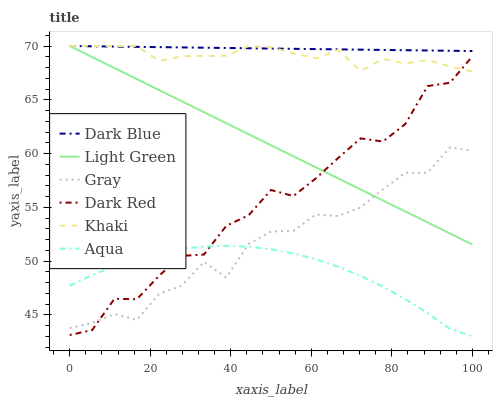Does Khaki have the minimum area under the curve?
Answer yes or no. No. Does Khaki have the maximum area under the curve?
Answer yes or no. No. Is Khaki the smoothest?
Answer yes or no. No. Is Khaki the roughest?
Answer yes or no. No. Does Khaki have the lowest value?
Answer yes or no. No. Does Dark Red have the highest value?
Answer yes or no. No. Is Aqua less than Dark Blue?
Answer yes or no. Yes. Is Light Green greater than Aqua?
Answer yes or no. Yes. Does Aqua intersect Dark Blue?
Answer yes or no. No. 